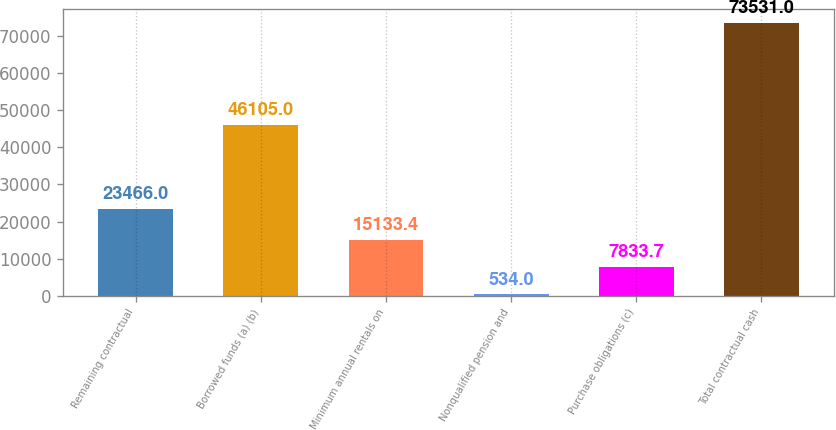Convert chart to OTSL. <chart><loc_0><loc_0><loc_500><loc_500><bar_chart><fcel>Remaining contractual<fcel>Borrowed funds (a) (b)<fcel>Minimum annual rentals on<fcel>Nonqualified pension and<fcel>Purchase obligations (c)<fcel>Total contractual cash<nl><fcel>23466<fcel>46105<fcel>15133.4<fcel>534<fcel>7833.7<fcel>73531<nl></chart> 